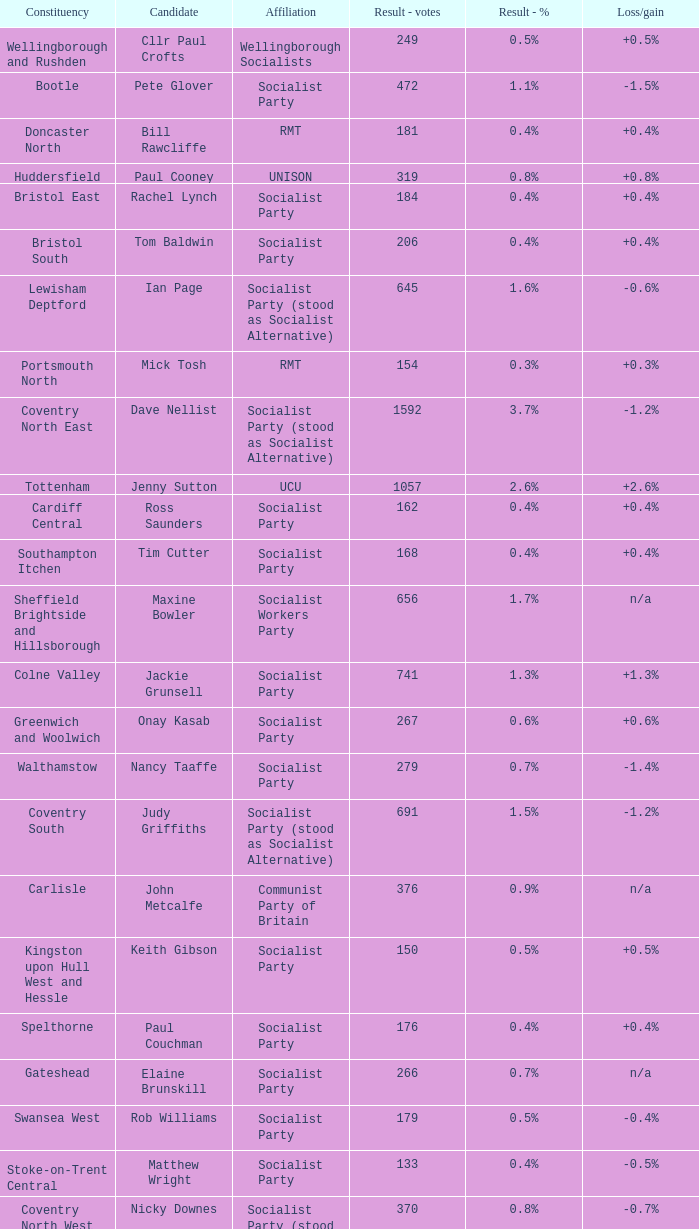What is every affiliation for the Tottenham constituency? UCU. 